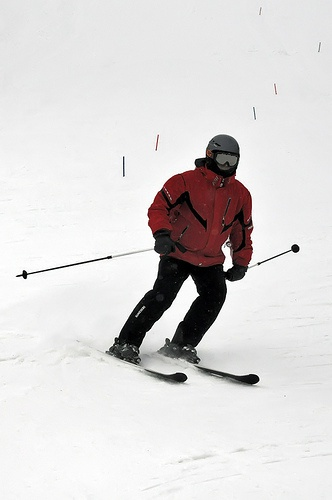Describe the objects in this image and their specific colors. I can see people in lightgray, black, maroon, gray, and white tones and skis in lightgray, black, gray, and darkgray tones in this image. 